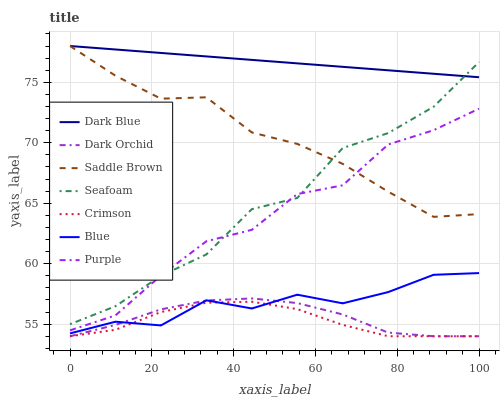Does Crimson have the minimum area under the curve?
Answer yes or no. Yes. Does Dark Blue have the maximum area under the curve?
Answer yes or no. Yes. Does Purple have the minimum area under the curve?
Answer yes or no. No. Does Purple have the maximum area under the curve?
Answer yes or no. No. Is Dark Blue the smoothest?
Answer yes or no. Yes. Is Seafoam the roughest?
Answer yes or no. Yes. Is Purple the smoothest?
Answer yes or no. No. Is Purple the roughest?
Answer yes or no. No. Does Dark Orchid have the lowest value?
Answer yes or no. Yes. Does Purple have the lowest value?
Answer yes or no. No. Does Saddle Brown have the highest value?
Answer yes or no. Yes. Does Purple have the highest value?
Answer yes or no. No. Is Dark Orchid less than Purple?
Answer yes or no. Yes. Is Dark Blue greater than Purple?
Answer yes or no. Yes. Does Dark Orchid intersect Crimson?
Answer yes or no. Yes. Is Dark Orchid less than Crimson?
Answer yes or no. No. Is Dark Orchid greater than Crimson?
Answer yes or no. No. Does Dark Orchid intersect Purple?
Answer yes or no. No. 